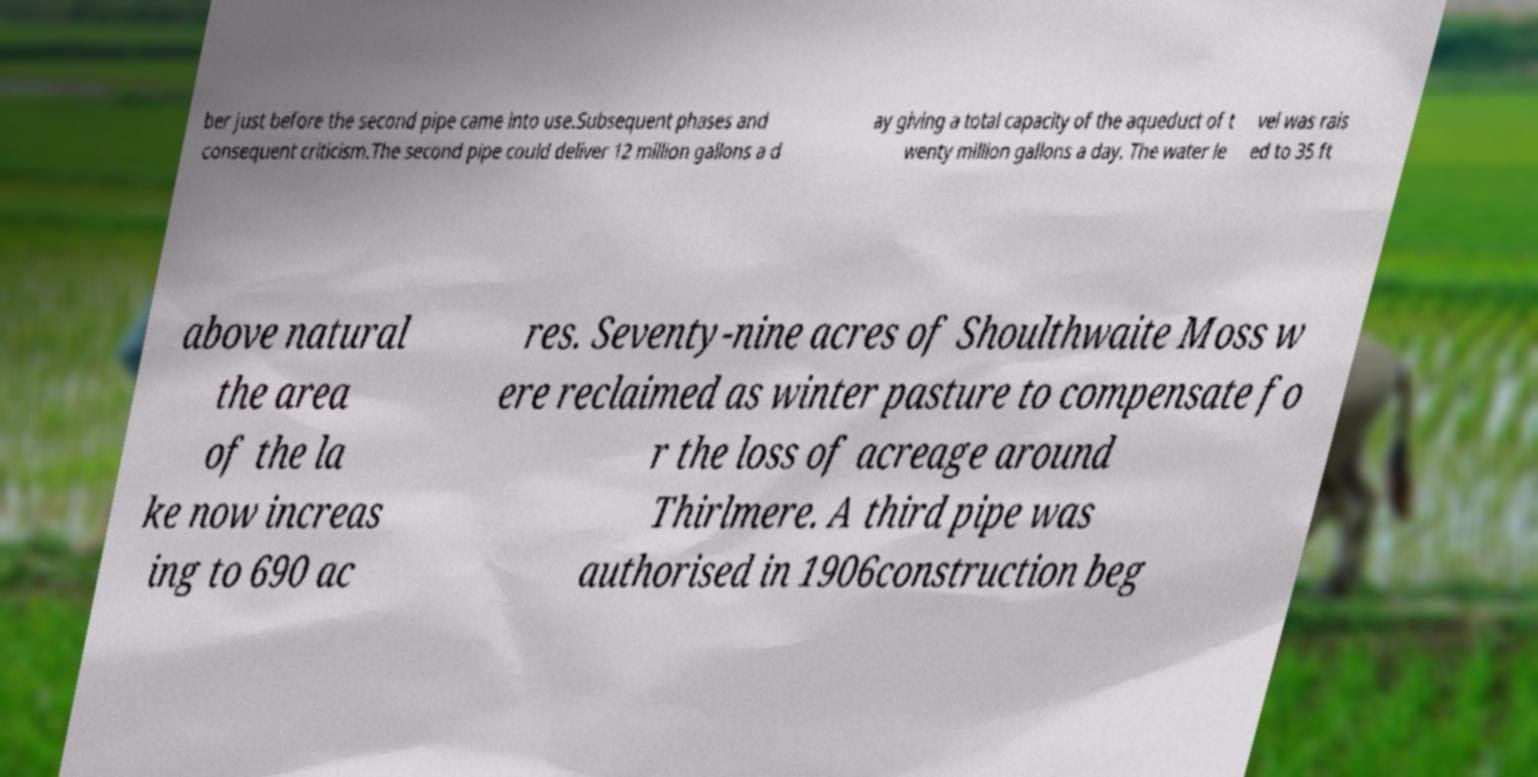There's text embedded in this image that I need extracted. Can you transcribe it verbatim? ber just before the second pipe came into use.Subsequent phases and consequent criticism.The second pipe could deliver 12 million gallons a d ay giving a total capacity of the aqueduct of t wenty million gallons a day. The water le vel was rais ed to 35 ft above natural the area of the la ke now increas ing to 690 ac res. Seventy-nine acres of Shoulthwaite Moss w ere reclaimed as winter pasture to compensate fo r the loss of acreage around Thirlmere. A third pipe was authorised in 1906construction beg 